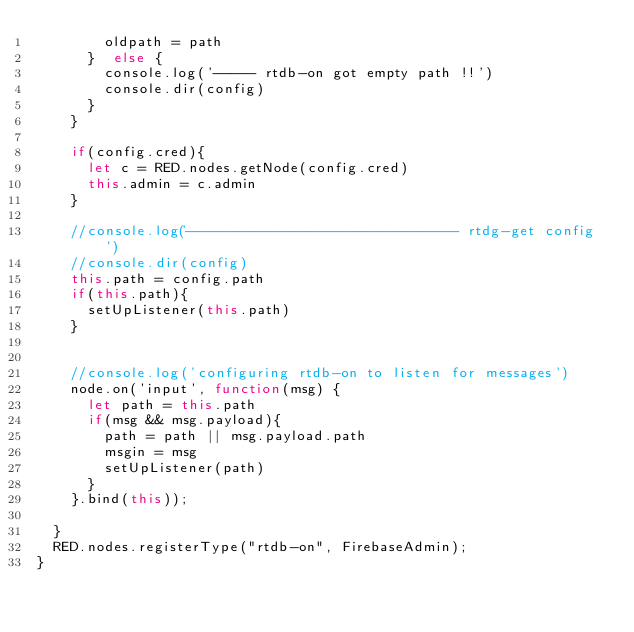<code> <loc_0><loc_0><loc_500><loc_500><_JavaScript_>        oldpath = path
      }  else {
        console.log('----- rtdb-on got empty path !!')
        console.dir(config)
      }
    }

    if(config.cred){
      let c = RED.nodes.getNode(config.cred)
      this.admin = c.admin
    }

    //console.log('------------------------------- rtdg-get config')
    //console.dir(config)
    this.path = config.path
    if(this.path){
      setUpListener(this.path)
    }


    //console.log('configuring rtdb-on to listen for messages')
    node.on('input', function(msg) {
      let path = this.path
      if(msg && msg.payload){
        path = path || msg.payload.path
        msgin = msg
        setUpListener(path)
      }
    }.bind(this));

  }
  RED.nodes.registerType("rtdb-on", FirebaseAdmin);
}</code> 